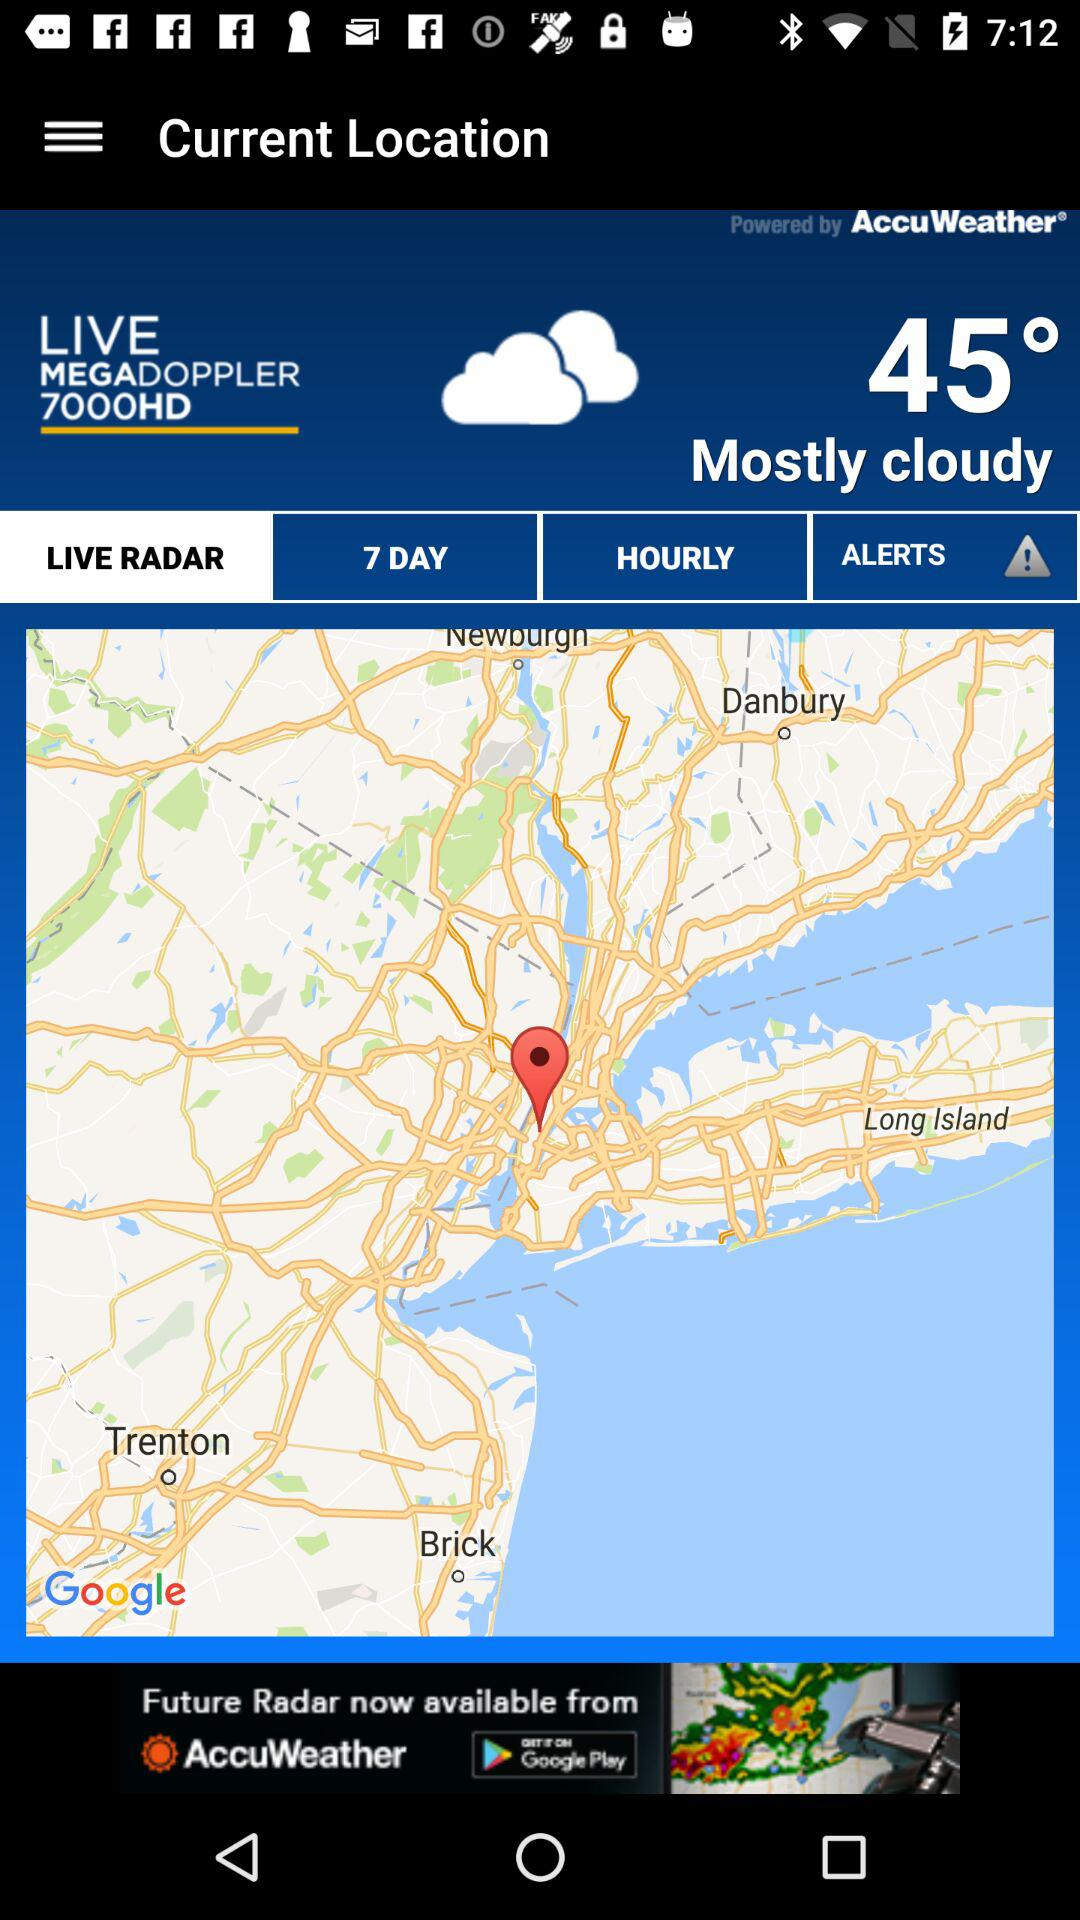How many degrees is the temperature above freezing?
Answer the question using a single word or phrase. 45 